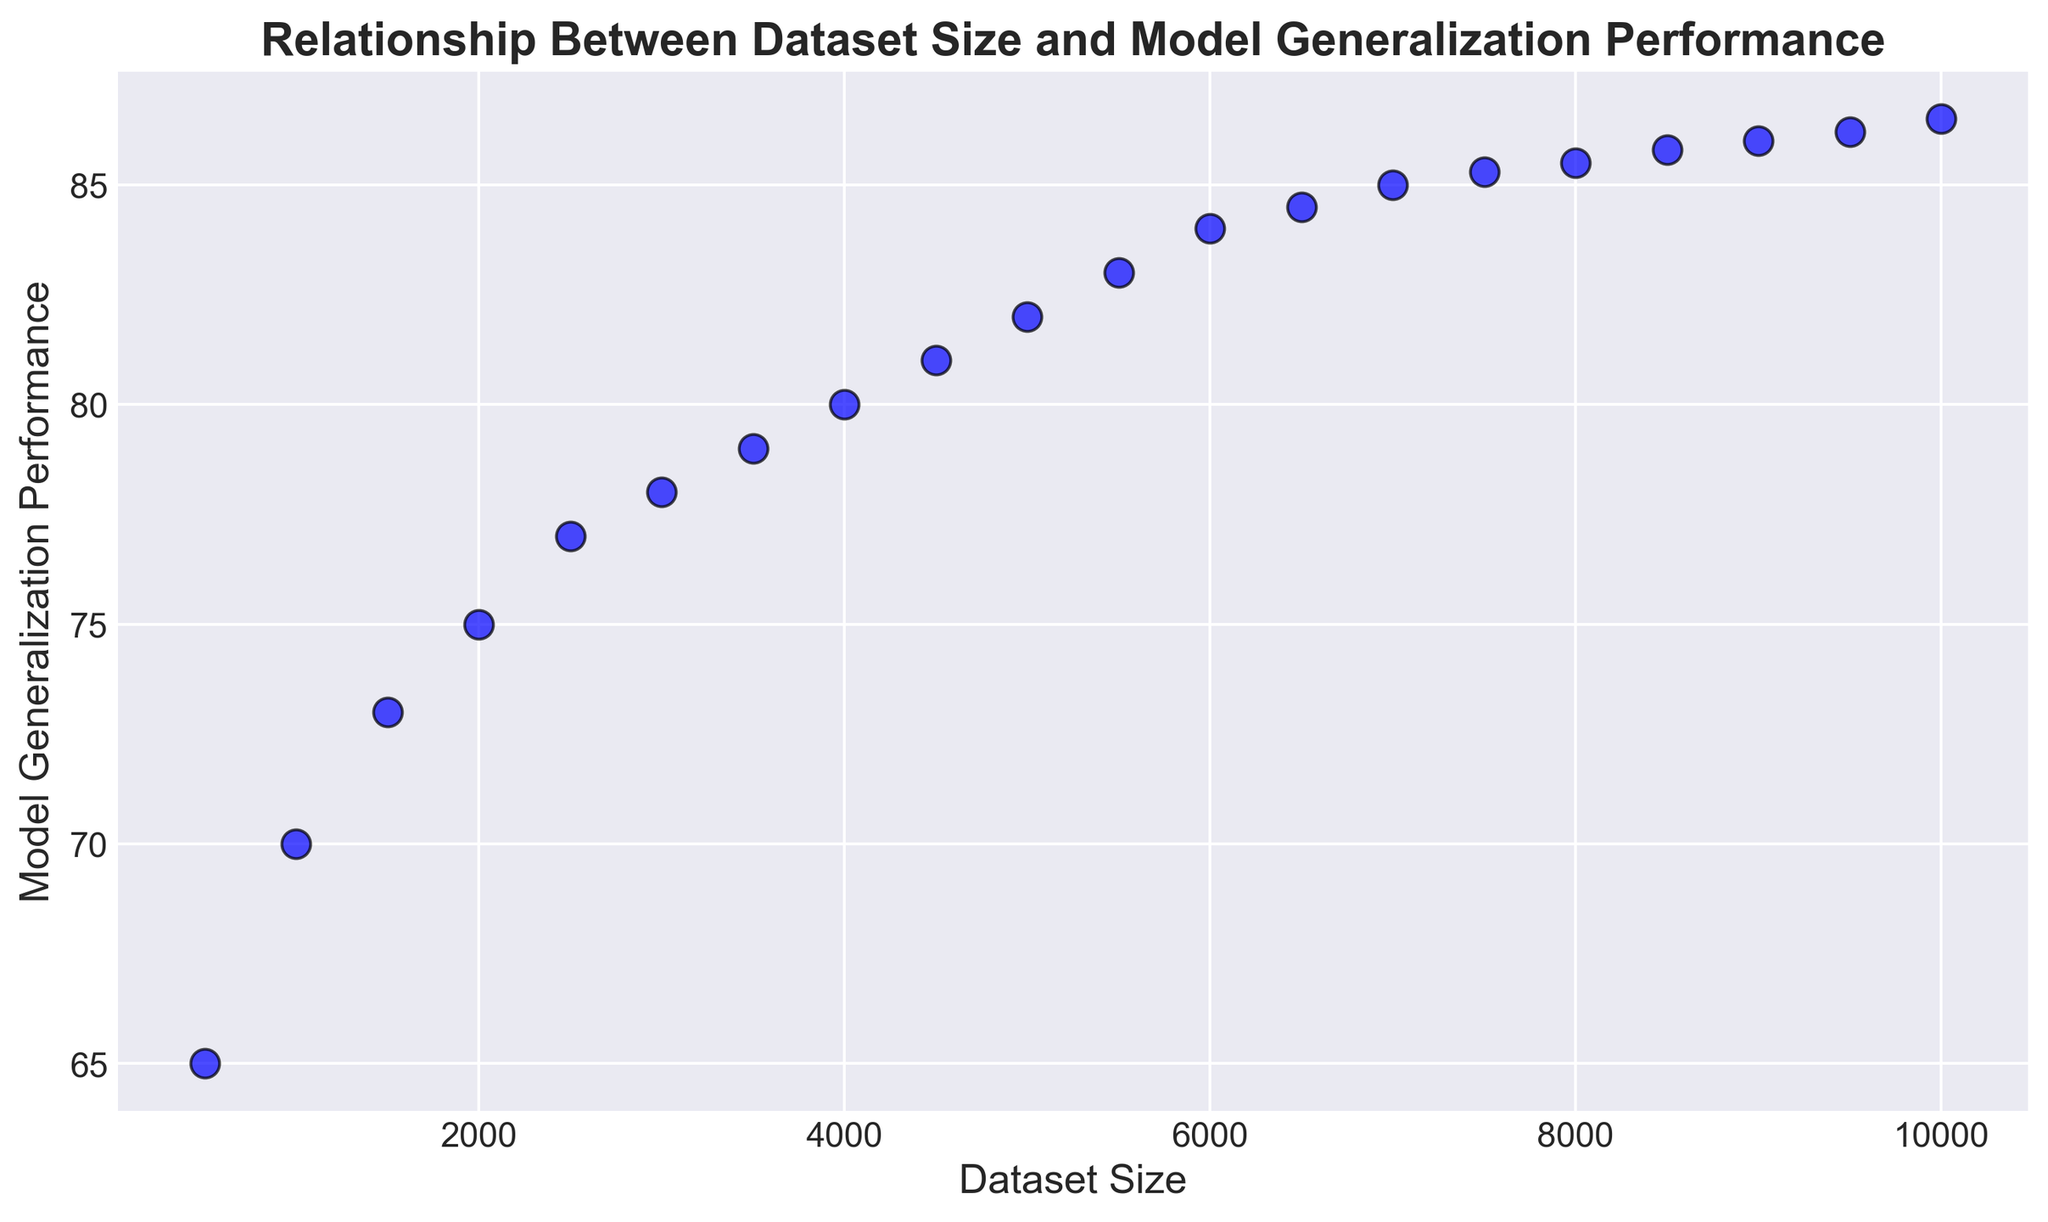What is the overall trend shown in the scatter plot? The scatter plot shows a positive trend: as the dataset size increases, the model generalization performance also increases. This suggests that using a larger dataset improves the model's generalization performance.
Answer: Positive trend What is the generalization performance at a dataset size of 5000? To find the generalization performance, look for the y-value corresponding to the x-value of 5000. At a dataset size of 5000, the generalization performance is 82.
Answer: 82 When the dataset size is doubled from 5000 to 10000, how much does the model generalization performance increase? The performance at 5000 is 82, and at 10000, it is 86.5. The increase in performance is 86.5 - 82 = 4.5.
Answer: 4.5 Compare the model generalization performances when the dataset sizes are 2000 and 6000. Which one is higher and by how much? The performance at 2000 is 75 and at 6000 is 84. The difference is 84 - 75 = 9.
Answer: 6000 by 9 What visual attribute distinguishes the data points in the scatter plot? The data points in the scatter plot are distinguished by their size, color, and edge color. They are all blue with black edges and have a size large enough to be clearly visible.
Answer: Size, color, and edge color How does the performance change between dataset sizes of 8000 and 8500? The performance at 8000 is 85.5, and at 8500, it is 85.8. The increase in performance is 85.8 - 85.5 = 0.3.
Answer: 0.3 What is the smallest dataset size where the model generalizes above 85? To find the smallest dataset size with performance above 85, look for the first y-value above 85. This occurs at a dataset size of 7000.
Answer: 7000 At which dataset size does the model generalization performance first reach 80? To find when the performance first reaches 80, look for the smallest x-value corresponding to a y-value of 80. This occurs at a dataset size of 4000.
Answer: 4000 Is the rate of increase in model performance constant as the dataset size increases? The rate of increase is not constant; it diminishes as the dataset size increases. For example, the increase from 500 to 1000 is 5, whereas from 9500 to 10000, it's 0.3.
Answer: No, it diminishes 